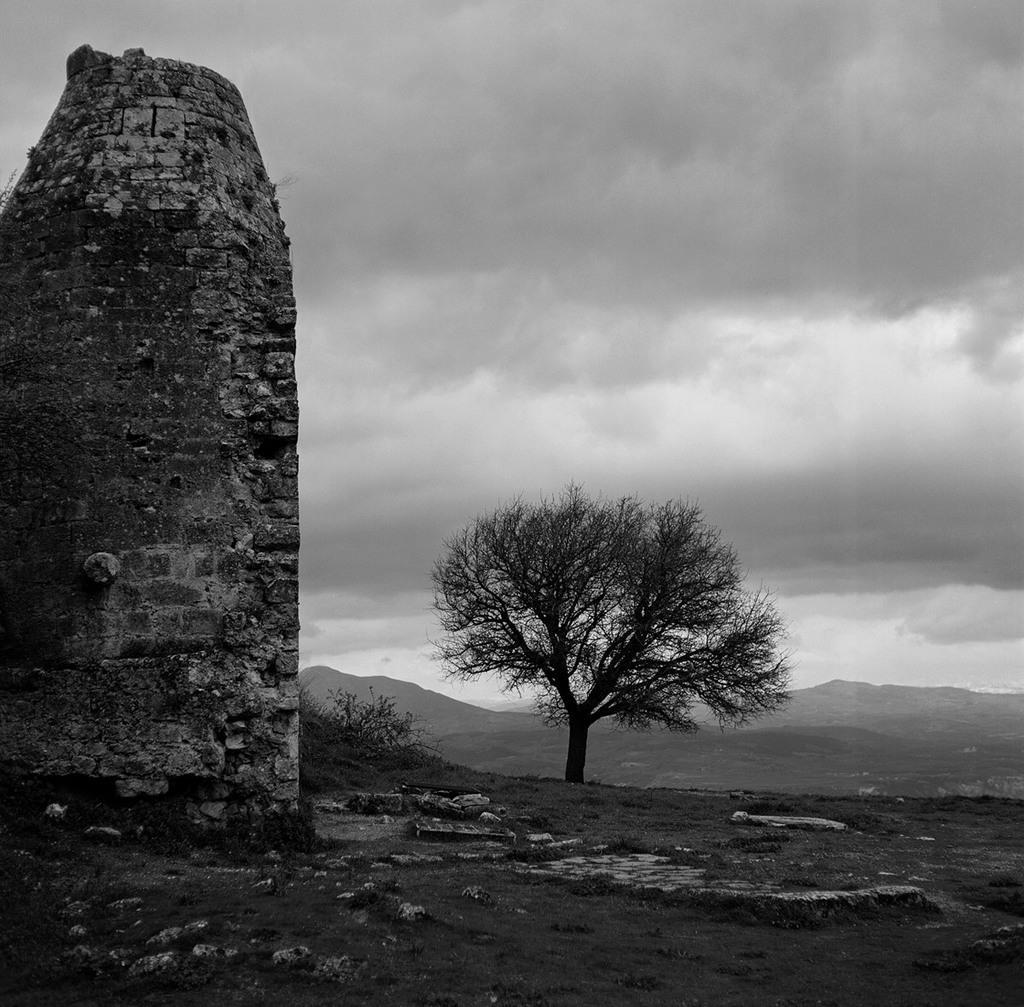In one or two sentences, can you explain what this image depicts? In this picture I can see a wall on the left side, in the middle there are trees and hills. At the top I can see the sky. 